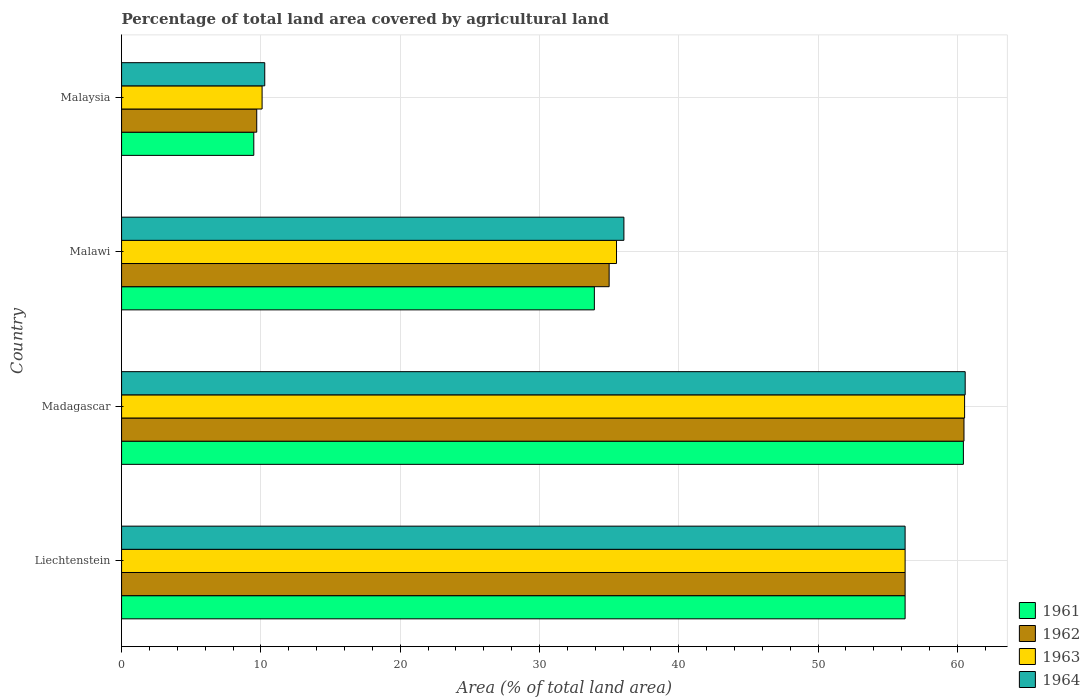Are the number of bars per tick equal to the number of legend labels?
Make the answer very short. Yes. Are the number of bars on each tick of the Y-axis equal?
Make the answer very short. Yes. How many bars are there on the 4th tick from the top?
Provide a succinct answer. 4. What is the label of the 3rd group of bars from the top?
Your response must be concise. Madagascar. What is the percentage of agricultural land in 1962 in Malaysia?
Ensure brevity in your answer.  9.7. Across all countries, what is the maximum percentage of agricultural land in 1962?
Your answer should be compact. 60.48. Across all countries, what is the minimum percentage of agricultural land in 1964?
Give a very brief answer. 10.28. In which country was the percentage of agricultural land in 1964 maximum?
Provide a succinct answer. Madagascar. In which country was the percentage of agricultural land in 1963 minimum?
Offer a very short reply. Malaysia. What is the total percentage of agricultural land in 1963 in the graph?
Make the answer very short. 162.39. What is the difference between the percentage of agricultural land in 1963 in Liechtenstein and that in Madagascar?
Ensure brevity in your answer.  -4.27. What is the difference between the percentage of agricultural land in 1964 in Malaysia and the percentage of agricultural land in 1962 in Madagascar?
Your answer should be compact. -50.2. What is the average percentage of agricultural land in 1963 per country?
Ensure brevity in your answer.  40.6. What is the difference between the percentage of agricultural land in 1964 and percentage of agricultural land in 1963 in Madagascar?
Make the answer very short. 0.04. In how many countries, is the percentage of agricultural land in 1962 greater than 54 %?
Your response must be concise. 2. What is the ratio of the percentage of agricultural land in 1962 in Malawi to that in Malaysia?
Make the answer very short. 3.61. Is the difference between the percentage of agricultural land in 1964 in Liechtenstein and Madagascar greater than the difference between the percentage of agricultural land in 1963 in Liechtenstein and Madagascar?
Your response must be concise. No. What is the difference between the highest and the second highest percentage of agricultural land in 1962?
Offer a very short reply. 4.23. What is the difference between the highest and the lowest percentage of agricultural land in 1962?
Make the answer very short. 50.77. Is the sum of the percentage of agricultural land in 1963 in Madagascar and Malawi greater than the maximum percentage of agricultural land in 1961 across all countries?
Your answer should be very brief. Yes. Is it the case that in every country, the sum of the percentage of agricultural land in 1963 and percentage of agricultural land in 1962 is greater than the sum of percentage of agricultural land in 1964 and percentage of agricultural land in 1961?
Offer a terse response. No. What does the 4th bar from the top in Liechtenstein represents?
Your answer should be compact. 1961. What does the 1st bar from the bottom in Liechtenstein represents?
Your response must be concise. 1961. What is the difference between two consecutive major ticks on the X-axis?
Your answer should be very brief. 10. Does the graph contain any zero values?
Your answer should be very brief. No. How many legend labels are there?
Provide a succinct answer. 4. What is the title of the graph?
Keep it short and to the point. Percentage of total land area covered by agricultural land. Does "2011" appear as one of the legend labels in the graph?
Offer a terse response. No. What is the label or title of the X-axis?
Provide a succinct answer. Area (% of total land area). What is the label or title of the Y-axis?
Your answer should be compact. Country. What is the Area (% of total land area) in 1961 in Liechtenstein?
Ensure brevity in your answer.  56.25. What is the Area (% of total land area) in 1962 in Liechtenstein?
Give a very brief answer. 56.25. What is the Area (% of total land area) of 1963 in Liechtenstein?
Ensure brevity in your answer.  56.25. What is the Area (% of total land area) of 1964 in Liechtenstein?
Your response must be concise. 56.25. What is the Area (% of total land area) in 1961 in Madagascar?
Provide a short and direct response. 60.43. What is the Area (% of total land area) in 1962 in Madagascar?
Your answer should be compact. 60.48. What is the Area (% of total land area) of 1963 in Madagascar?
Make the answer very short. 60.52. What is the Area (% of total land area) of 1964 in Madagascar?
Offer a terse response. 60.56. What is the Area (% of total land area) in 1961 in Malawi?
Keep it short and to the point. 33.94. What is the Area (% of total land area) of 1962 in Malawi?
Your answer should be very brief. 35. What is the Area (% of total land area) in 1963 in Malawi?
Offer a terse response. 35.53. What is the Area (% of total land area) in 1964 in Malawi?
Your response must be concise. 36.06. What is the Area (% of total land area) in 1961 in Malaysia?
Offer a very short reply. 9.49. What is the Area (% of total land area) in 1962 in Malaysia?
Ensure brevity in your answer.  9.7. What is the Area (% of total land area) of 1963 in Malaysia?
Provide a succinct answer. 10.09. What is the Area (% of total land area) in 1964 in Malaysia?
Your answer should be very brief. 10.28. Across all countries, what is the maximum Area (% of total land area) in 1961?
Provide a succinct answer. 60.43. Across all countries, what is the maximum Area (% of total land area) of 1962?
Offer a very short reply. 60.48. Across all countries, what is the maximum Area (% of total land area) in 1963?
Give a very brief answer. 60.52. Across all countries, what is the maximum Area (% of total land area) of 1964?
Provide a short and direct response. 60.56. Across all countries, what is the minimum Area (% of total land area) of 1961?
Keep it short and to the point. 9.49. Across all countries, what is the minimum Area (% of total land area) in 1962?
Provide a succinct answer. 9.7. Across all countries, what is the minimum Area (% of total land area) in 1963?
Keep it short and to the point. 10.09. Across all countries, what is the minimum Area (% of total land area) in 1964?
Provide a short and direct response. 10.28. What is the total Area (% of total land area) of 1961 in the graph?
Ensure brevity in your answer.  160.12. What is the total Area (% of total land area) of 1962 in the graph?
Provide a short and direct response. 161.43. What is the total Area (% of total land area) in 1963 in the graph?
Ensure brevity in your answer.  162.39. What is the total Area (% of total land area) of 1964 in the graph?
Your answer should be compact. 163.15. What is the difference between the Area (% of total land area) of 1961 in Liechtenstein and that in Madagascar?
Make the answer very short. -4.18. What is the difference between the Area (% of total land area) in 1962 in Liechtenstein and that in Madagascar?
Offer a terse response. -4.23. What is the difference between the Area (% of total land area) of 1963 in Liechtenstein and that in Madagascar?
Provide a short and direct response. -4.27. What is the difference between the Area (% of total land area) of 1964 in Liechtenstein and that in Madagascar?
Make the answer very short. -4.31. What is the difference between the Area (% of total land area) of 1961 in Liechtenstein and that in Malawi?
Give a very brief answer. 22.31. What is the difference between the Area (% of total land area) of 1962 in Liechtenstein and that in Malawi?
Provide a short and direct response. 21.25. What is the difference between the Area (% of total land area) in 1963 in Liechtenstein and that in Malawi?
Offer a terse response. 20.72. What is the difference between the Area (% of total land area) in 1964 in Liechtenstein and that in Malawi?
Your answer should be very brief. 20.19. What is the difference between the Area (% of total land area) of 1961 in Liechtenstein and that in Malaysia?
Your answer should be very brief. 46.76. What is the difference between the Area (% of total land area) in 1962 in Liechtenstein and that in Malaysia?
Keep it short and to the point. 46.55. What is the difference between the Area (% of total land area) in 1963 in Liechtenstein and that in Malaysia?
Keep it short and to the point. 46.16. What is the difference between the Area (% of total land area) in 1964 in Liechtenstein and that in Malaysia?
Keep it short and to the point. 45.97. What is the difference between the Area (% of total land area) in 1961 in Madagascar and that in Malawi?
Your response must be concise. 26.49. What is the difference between the Area (% of total land area) of 1962 in Madagascar and that in Malawi?
Your response must be concise. 25.48. What is the difference between the Area (% of total land area) in 1963 in Madagascar and that in Malawi?
Your answer should be very brief. 24.99. What is the difference between the Area (% of total land area) of 1964 in Madagascar and that in Malawi?
Offer a very short reply. 24.5. What is the difference between the Area (% of total land area) in 1961 in Madagascar and that in Malaysia?
Your answer should be very brief. 50.94. What is the difference between the Area (% of total land area) in 1962 in Madagascar and that in Malaysia?
Your response must be concise. 50.77. What is the difference between the Area (% of total land area) of 1963 in Madagascar and that in Malaysia?
Give a very brief answer. 50.43. What is the difference between the Area (% of total land area) in 1964 in Madagascar and that in Malaysia?
Your answer should be compact. 50.28. What is the difference between the Area (% of total land area) in 1961 in Malawi and that in Malaysia?
Ensure brevity in your answer.  24.45. What is the difference between the Area (% of total land area) in 1962 in Malawi and that in Malaysia?
Your response must be concise. 25.3. What is the difference between the Area (% of total land area) in 1963 in Malawi and that in Malaysia?
Offer a very short reply. 25.45. What is the difference between the Area (% of total land area) of 1964 in Malawi and that in Malaysia?
Your answer should be very brief. 25.78. What is the difference between the Area (% of total land area) in 1961 in Liechtenstein and the Area (% of total land area) in 1962 in Madagascar?
Make the answer very short. -4.23. What is the difference between the Area (% of total land area) in 1961 in Liechtenstein and the Area (% of total land area) in 1963 in Madagascar?
Your response must be concise. -4.27. What is the difference between the Area (% of total land area) in 1961 in Liechtenstein and the Area (% of total land area) in 1964 in Madagascar?
Provide a short and direct response. -4.31. What is the difference between the Area (% of total land area) in 1962 in Liechtenstein and the Area (% of total land area) in 1963 in Madagascar?
Offer a very short reply. -4.27. What is the difference between the Area (% of total land area) in 1962 in Liechtenstein and the Area (% of total land area) in 1964 in Madagascar?
Provide a succinct answer. -4.31. What is the difference between the Area (% of total land area) of 1963 in Liechtenstein and the Area (% of total land area) of 1964 in Madagascar?
Your answer should be compact. -4.31. What is the difference between the Area (% of total land area) of 1961 in Liechtenstein and the Area (% of total land area) of 1962 in Malawi?
Make the answer very short. 21.25. What is the difference between the Area (% of total land area) of 1961 in Liechtenstein and the Area (% of total land area) of 1963 in Malawi?
Offer a very short reply. 20.72. What is the difference between the Area (% of total land area) of 1961 in Liechtenstein and the Area (% of total land area) of 1964 in Malawi?
Ensure brevity in your answer.  20.19. What is the difference between the Area (% of total land area) in 1962 in Liechtenstein and the Area (% of total land area) in 1963 in Malawi?
Your response must be concise. 20.72. What is the difference between the Area (% of total land area) of 1962 in Liechtenstein and the Area (% of total land area) of 1964 in Malawi?
Your answer should be very brief. 20.19. What is the difference between the Area (% of total land area) in 1963 in Liechtenstein and the Area (% of total land area) in 1964 in Malawi?
Offer a very short reply. 20.19. What is the difference between the Area (% of total land area) of 1961 in Liechtenstein and the Area (% of total land area) of 1962 in Malaysia?
Keep it short and to the point. 46.55. What is the difference between the Area (% of total land area) of 1961 in Liechtenstein and the Area (% of total land area) of 1963 in Malaysia?
Give a very brief answer. 46.16. What is the difference between the Area (% of total land area) in 1961 in Liechtenstein and the Area (% of total land area) in 1964 in Malaysia?
Provide a succinct answer. 45.97. What is the difference between the Area (% of total land area) of 1962 in Liechtenstein and the Area (% of total land area) of 1963 in Malaysia?
Offer a very short reply. 46.16. What is the difference between the Area (% of total land area) in 1962 in Liechtenstein and the Area (% of total land area) in 1964 in Malaysia?
Your answer should be very brief. 45.97. What is the difference between the Area (% of total land area) in 1963 in Liechtenstein and the Area (% of total land area) in 1964 in Malaysia?
Offer a terse response. 45.97. What is the difference between the Area (% of total land area) of 1961 in Madagascar and the Area (% of total land area) of 1962 in Malawi?
Ensure brevity in your answer.  25.43. What is the difference between the Area (% of total land area) in 1961 in Madagascar and the Area (% of total land area) in 1963 in Malawi?
Ensure brevity in your answer.  24.9. What is the difference between the Area (% of total land area) in 1961 in Madagascar and the Area (% of total land area) in 1964 in Malawi?
Offer a terse response. 24.37. What is the difference between the Area (% of total land area) of 1962 in Madagascar and the Area (% of total land area) of 1963 in Malawi?
Give a very brief answer. 24.94. What is the difference between the Area (% of total land area) in 1962 in Madagascar and the Area (% of total land area) in 1964 in Malawi?
Your response must be concise. 24.41. What is the difference between the Area (% of total land area) in 1963 in Madagascar and the Area (% of total land area) in 1964 in Malawi?
Your answer should be compact. 24.46. What is the difference between the Area (% of total land area) in 1961 in Madagascar and the Area (% of total land area) in 1962 in Malaysia?
Make the answer very short. 50.73. What is the difference between the Area (% of total land area) in 1961 in Madagascar and the Area (% of total land area) in 1963 in Malaysia?
Provide a short and direct response. 50.35. What is the difference between the Area (% of total land area) of 1961 in Madagascar and the Area (% of total land area) of 1964 in Malaysia?
Offer a terse response. 50.16. What is the difference between the Area (% of total land area) in 1962 in Madagascar and the Area (% of total land area) in 1963 in Malaysia?
Provide a short and direct response. 50.39. What is the difference between the Area (% of total land area) in 1962 in Madagascar and the Area (% of total land area) in 1964 in Malaysia?
Your answer should be compact. 50.2. What is the difference between the Area (% of total land area) of 1963 in Madagascar and the Area (% of total land area) of 1964 in Malaysia?
Give a very brief answer. 50.24. What is the difference between the Area (% of total land area) in 1961 in Malawi and the Area (% of total land area) in 1962 in Malaysia?
Provide a short and direct response. 24.24. What is the difference between the Area (% of total land area) of 1961 in Malawi and the Area (% of total land area) of 1963 in Malaysia?
Your answer should be very brief. 23.85. What is the difference between the Area (% of total land area) in 1961 in Malawi and the Area (% of total land area) in 1964 in Malaysia?
Keep it short and to the point. 23.66. What is the difference between the Area (% of total land area) of 1962 in Malawi and the Area (% of total land area) of 1963 in Malaysia?
Offer a terse response. 24.91. What is the difference between the Area (% of total land area) of 1962 in Malawi and the Area (% of total land area) of 1964 in Malaysia?
Keep it short and to the point. 24.72. What is the difference between the Area (% of total land area) in 1963 in Malawi and the Area (% of total land area) in 1964 in Malaysia?
Offer a terse response. 25.25. What is the average Area (% of total land area) in 1961 per country?
Provide a short and direct response. 40.03. What is the average Area (% of total land area) in 1962 per country?
Give a very brief answer. 40.36. What is the average Area (% of total land area) in 1963 per country?
Provide a short and direct response. 40.6. What is the average Area (% of total land area) in 1964 per country?
Your answer should be very brief. 40.79. What is the difference between the Area (% of total land area) of 1961 and Area (% of total land area) of 1962 in Liechtenstein?
Provide a short and direct response. 0. What is the difference between the Area (% of total land area) of 1961 and Area (% of total land area) of 1964 in Liechtenstein?
Give a very brief answer. 0. What is the difference between the Area (% of total land area) of 1961 and Area (% of total land area) of 1962 in Madagascar?
Your answer should be compact. -0.04. What is the difference between the Area (% of total land area) of 1961 and Area (% of total land area) of 1963 in Madagascar?
Offer a very short reply. -0.09. What is the difference between the Area (% of total land area) in 1961 and Area (% of total land area) in 1964 in Madagascar?
Your answer should be compact. -0.13. What is the difference between the Area (% of total land area) in 1962 and Area (% of total land area) in 1963 in Madagascar?
Keep it short and to the point. -0.04. What is the difference between the Area (% of total land area) in 1962 and Area (% of total land area) in 1964 in Madagascar?
Give a very brief answer. -0.09. What is the difference between the Area (% of total land area) of 1963 and Area (% of total land area) of 1964 in Madagascar?
Your answer should be compact. -0.04. What is the difference between the Area (% of total land area) of 1961 and Area (% of total land area) of 1962 in Malawi?
Offer a very short reply. -1.06. What is the difference between the Area (% of total land area) in 1961 and Area (% of total land area) in 1963 in Malawi?
Keep it short and to the point. -1.59. What is the difference between the Area (% of total land area) of 1961 and Area (% of total land area) of 1964 in Malawi?
Your response must be concise. -2.12. What is the difference between the Area (% of total land area) of 1962 and Area (% of total land area) of 1963 in Malawi?
Your answer should be compact. -0.53. What is the difference between the Area (% of total land area) in 1962 and Area (% of total land area) in 1964 in Malawi?
Provide a succinct answer. -1.06. What is the difference between the Area (% of total land area) in 1963 and Area (% of total land area) in 1964 in Malawi?
Your answer should be compact. -0.53. What is the difference between the Area (% of total land area) in 1961 and Area (% of total land area) in 1962 in Malaysia?
Keep it short and to the point. -0.21. What is the difference between the Area (% of total land area) of 1961 and Area (% of total land area) of 1963 in Malaysia?
Your response must be concise. -0.6. What is the difference between the Area (% of total land area) in 1961 and Area (% of total land area) in 1964 in Malaysia?
Provide a short and direct response. -0.79. What is the difference between the Area (% of total land area) in 1962 and Area (% of total land area) in 1963 in Malaysia?
Your answer should be very brief. -0.38. What is the difference between the Area (% of total land area) of 1962 and Area (% of total land area) of 1964 in Malaysia?
Give a very brief answer. -0.58. What is the difference between the Area (% of total land area) in 1963 and Area (% of total land area) in 1964 in Malaysia?
Offer a terse response. -0.19. What is the ratio of the Area (% of total land area) of 1961 in Liechtenstein to that in Madagascar?
Your answer should be compact. 0.93. What is the ratio of the Area (% of total land area) of 1962 in Liechtenstein to that in Madagascar?
Offer a very short reply. 0.93. What is the ratio of the Area (% of total land area) of 1963 in Liechtenstein to that in Madagascar?
Your response must be concise. 0.93. What is the ratio of the Area (% of total land area) in 1964 in Liechtenstein to that in Madagascar?
Provide a succinct answer. 0.93. What is the ratio of the Area (% of total land area) in 1961 in Liechtenstein to that in Malawi?
Provide a succinct answer. 1.66. What is the ratio of the Area (% of total land area) in 1962 in Liechtenstein to that in Malawi?
Give a very brief answer. 1.61. What is the ratio of the Area (% of total land area) in 1963 in Liechtenstein to that in Malawi?
Ensure brevity in your answer.  1.58. What is the ratio of the Area (% of total land area) in 1964 in Liechtenstein to that in Malawi?
Offer a terse response. 1.56. What is the ratio of the Area (% of total land area) in 1961 in Liechtenstein to that in Malaysia?
Offer a terse response. 5.93. What is the ratio of the Area (% of total land area) in 1962 in Liechtenstein to that in Malaysia?
Your answer should be very brief. 5.8. What is the ratio of the Area (% of total land area) of 1963 in Liechtenstein to that in Malaysia?
Ensure brevity in your answer.  5.58. What is the ratio of the Area (% of total land area) in 1964 in Liechtenstein to that in Malaysia?
Make the answer very short. 5.47. What is the ratio of the Area (% of total land area) of 1961 in Madagascar to that in Malawi?
Keep it short and to the point. 1.78. What is the ratio of the Area (% of total land area) of 1962 in Madagascar to that in Malawi?
Ensure brevity in your answer.  1.73. What is the ratio of the Area (% of total land area) in 1963 in Madagascar to that in Malawi?
Provide a short and direct response. 1.7. What is the ratio of the Area (% of total land area) of 1964 in Madagascar to that in Malawi?
Your response must be concise. 1.68. What is the ratio of the Area (% of total land area) of 1961 in Madagascar to that in Malaysia?
Make the answer very short. 6.37. What is the ratio of the Area (% of total land area) in 1962 in Madagascar to that in Malaysia?
Ensure brevity in your answer.  6.23. What is the ratio of the Area (% of total land area) of 1963 in Madagascar to that in Malaysia?
Give a very brief answer. 6. What is the ratio of the Area (% of total land area) in 1964 in Madagascar to that in Malaysia?
Your response must be concise. 5.89. What is the ratio of the Area (% of total land area) in 1961 in Malawi to that in Malaysia?
Offer a very short reply. 3.58. What is the ratio of the Area (% of total land area) in 1962 in Malawi to that in Malaysia?
Provide a succinct answer. 3.61. What is the ratio of the Area (% of total land area) of 1963 in Malawi to that in Malaysia?
Your response must be concise. 3.52. What is the ratio of the Area (% of total land area) of 1964 in Malawi to that in Malaysia?
Your answer should be very brief. 3.51. What is the difference between the highest and the second highest Area (% of total land area) of 1961?
Make the answer very short. 4.18. What is the difference between the highest and the second highest Area (% of total land area) of 1962?
Make the answer very short. 4.23. What is the difference between the highest and the second highest Area (% of total land area) of 1963?
Provide a succinct answer. 4.27. What is the difference between the highest and the second highest Area (% of total land area) of 1964?
Give a very brief answer. 4.31. What is the difference between the highest and the lowest Area (% of total land area) of 1961?
Keep it short and to the point. 50.94. What is the difference between the highest and the lowest Area (% of total land area) of 1962?
Make the answer very short. 50.77. What is the difference between the highest and the lowest Area (% of total land area) in 1963?
Your answer should be very brief. 50.43. What is the difference between the highest and the lowest Area (% of total land area) of 1964?
Keep it short and to the point. 50.28. 